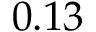Convert formula to latex. <formula><loc_0><loc_0><loc_500><loc_500>0 . 1 3</formula> 